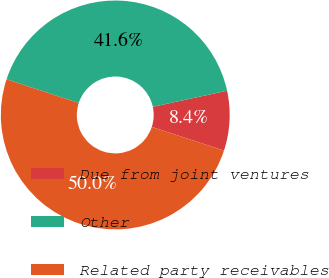<chart> <loc_0><loc_0><loc_500><loc_500><pie_chart><fcel>Due from joint ventures<fcel>Other<fcel>Related party receivables<nl><fcel>8.44%<fcel>41.56%<fcel>50.0%<nl></chart> 